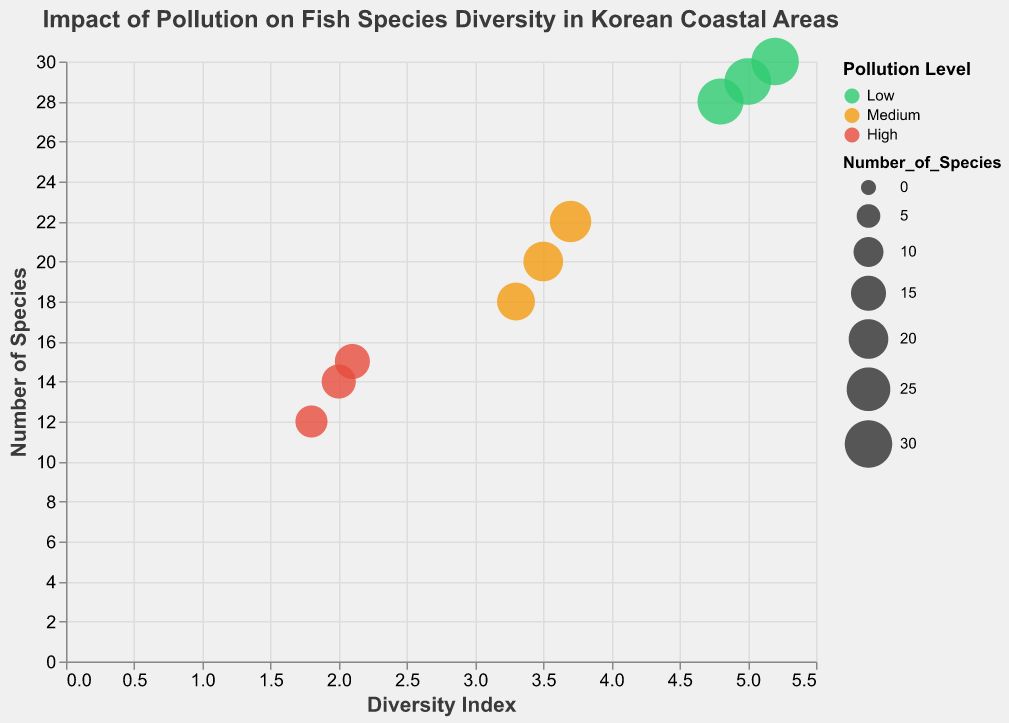How many coastal areas are represented in the figure? Count the number of distinct coastal areas in the figure.
Answer: 9 What is the title of the figure? Refer to the title displayed at the top of the figure.
Answer: Impact of Pollution on Fish Species Diversity in Korean Coastal Areas Which coastal area has the highest Diversity Index? Identify the data point with the highest value on the x-axis (Diversity Index) and note the corresponding coastal area.
Answer: Jeju What is the Pollution Level of the coastal area with the highest Number of Species? Find the data point with the highest value on the y-axis (Number of Species) and check the color legend to determine the Pollution Level.
Answer: Low What is the average Diversity Index for coastal areas with Medium Pollution Level? Identify the data points with Medium Pollution Level, sum their Diversity Index values, and divide by the number of such points.
Answer: (3.5 + 3.3 + 3.7) / 3 = 3.5 Which coastal area has the lowest Number of Species, and what is its Diversity Index? Find the data point with the lowest value on the y-axis (Number of Species) and note the Coastal Area and its Diversity Index value.
Answer: Ulsan, 1.8 Compare the Number of Species for coastal areas with Low and High Pollution Levels. Which group tends to have higher diversity? Observe the sizes of bubbles (Number of Species) within the Low and High Pollution Level groups. Low Pollution Level coastal areas have larger bubbles (higher diversity).
Answer: Low How does the Diversity Index relate to the Number of Species across different Pollution Levels? Examine the general trend in the bubbles' positions on the x (Diversity Index) and y (Number of Species) axes and their colors (Pollution Levels).
Answer: Higher Diversity Index tends to correspond with a higher Number of Species, and Low Pollution Level areas generally have higher values on both axes What is the difference in the Number of Species between Yeosu and Busan? Find the Number of Species for Yeosu and Busan and calculate the difference.
Answer: 18 - 15 = 3 